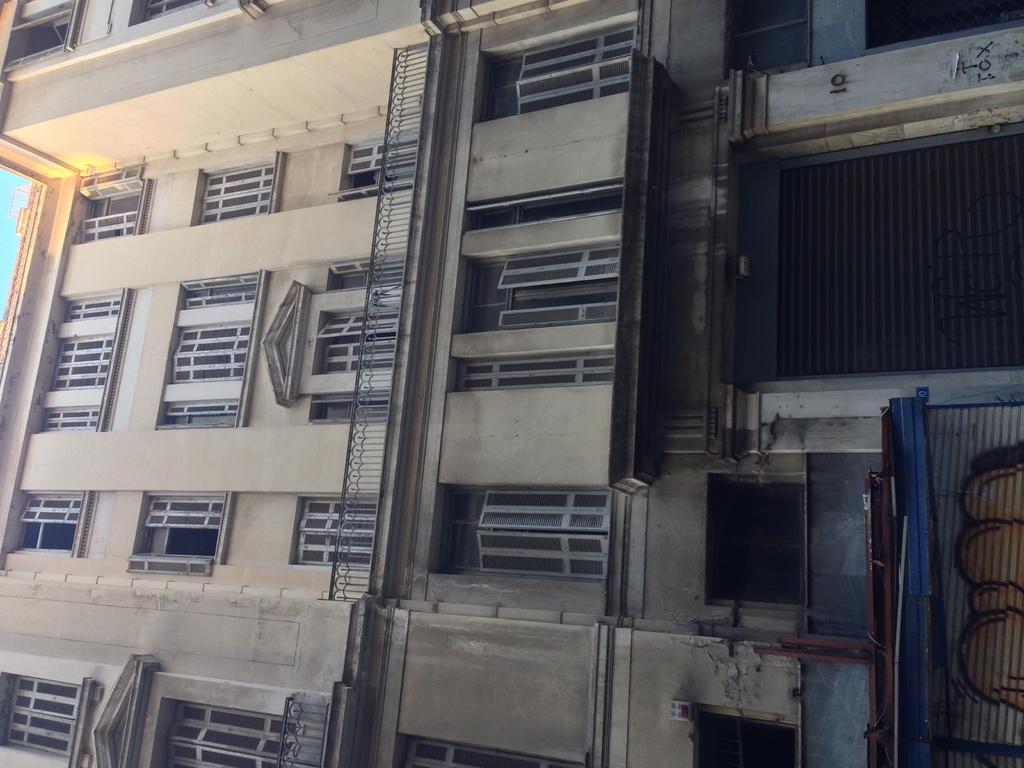How would you summarize this image in a sentence or two? In this image there is a building, railing, glass windows, shutters and some objects. 